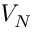Convert formula to latex. <formula><loc_0><loc_0><loc_500><loc_500>V _ { N }</formula> 